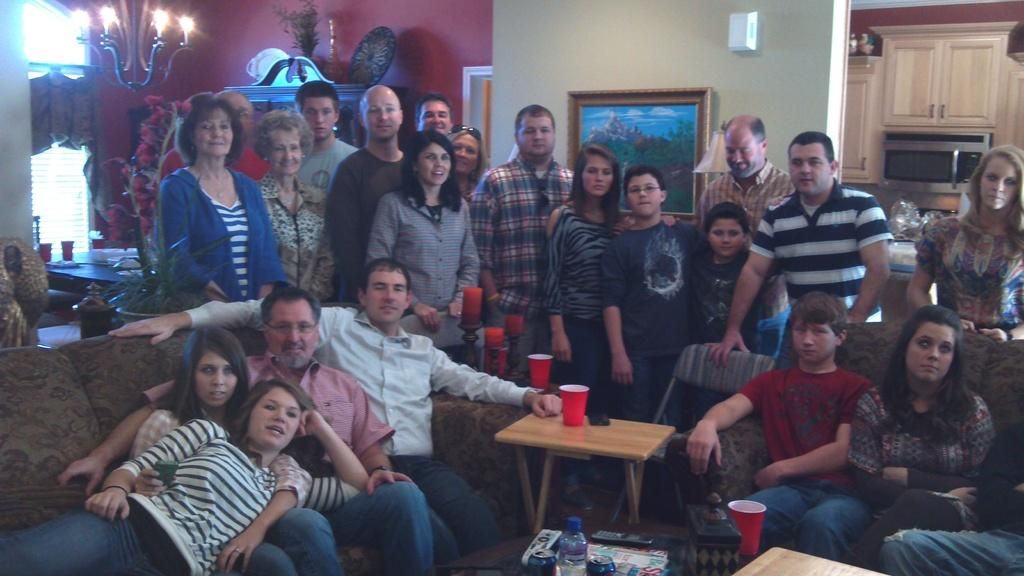What type of structure can be seen in the image? There is a wall in the image. What is hanging on the wall? There is a photo frame in the image. What are the people in the image doing? There are people standing and sitting in the image. What type of furniture is present in the image? There are sofas in the image. What is on the table in the image? There are glasses and plates on the table. Can you tell me how many boats are docked at the harbor in the image? There is no harbor or boats present in the image; it features a wall, a photo frame, people, sofas, a table, glasses, and plates. What type of jewel is being worn by the person in the image? There is no person wearing a jewel in the image. 